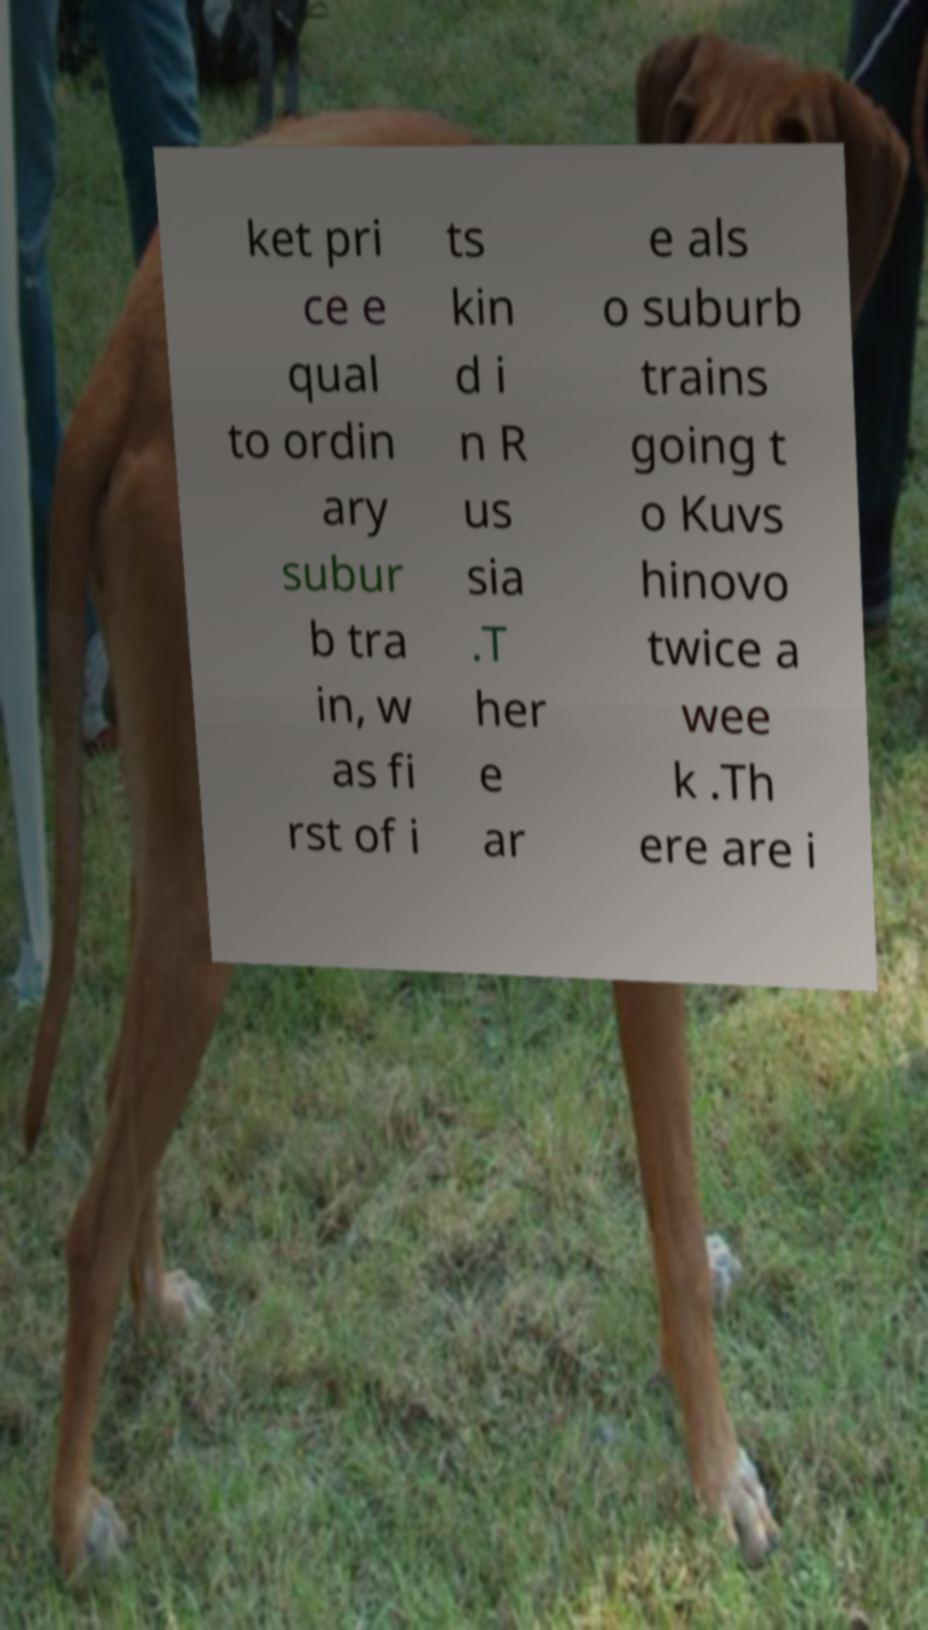Can you read and provide the text displayed in the image?This photo seems to have some interesting text. Can you extract and type it out for me? ket pri ce e qual to ordin ary subur b tra in, w as fi rst of i ts kin d i n R us sia .T her e ar e als o suburb trains going t o Kuvs hinovo twice a wee k .Th ere are i 